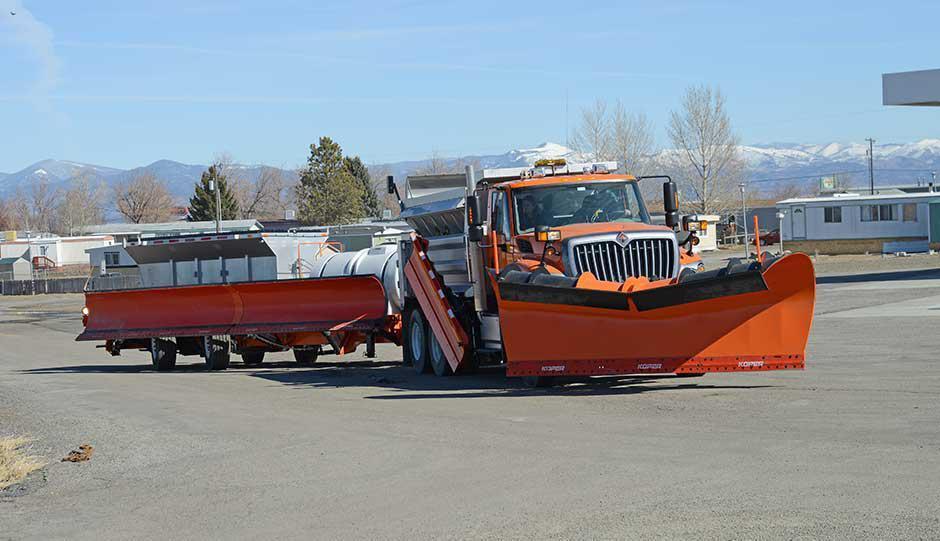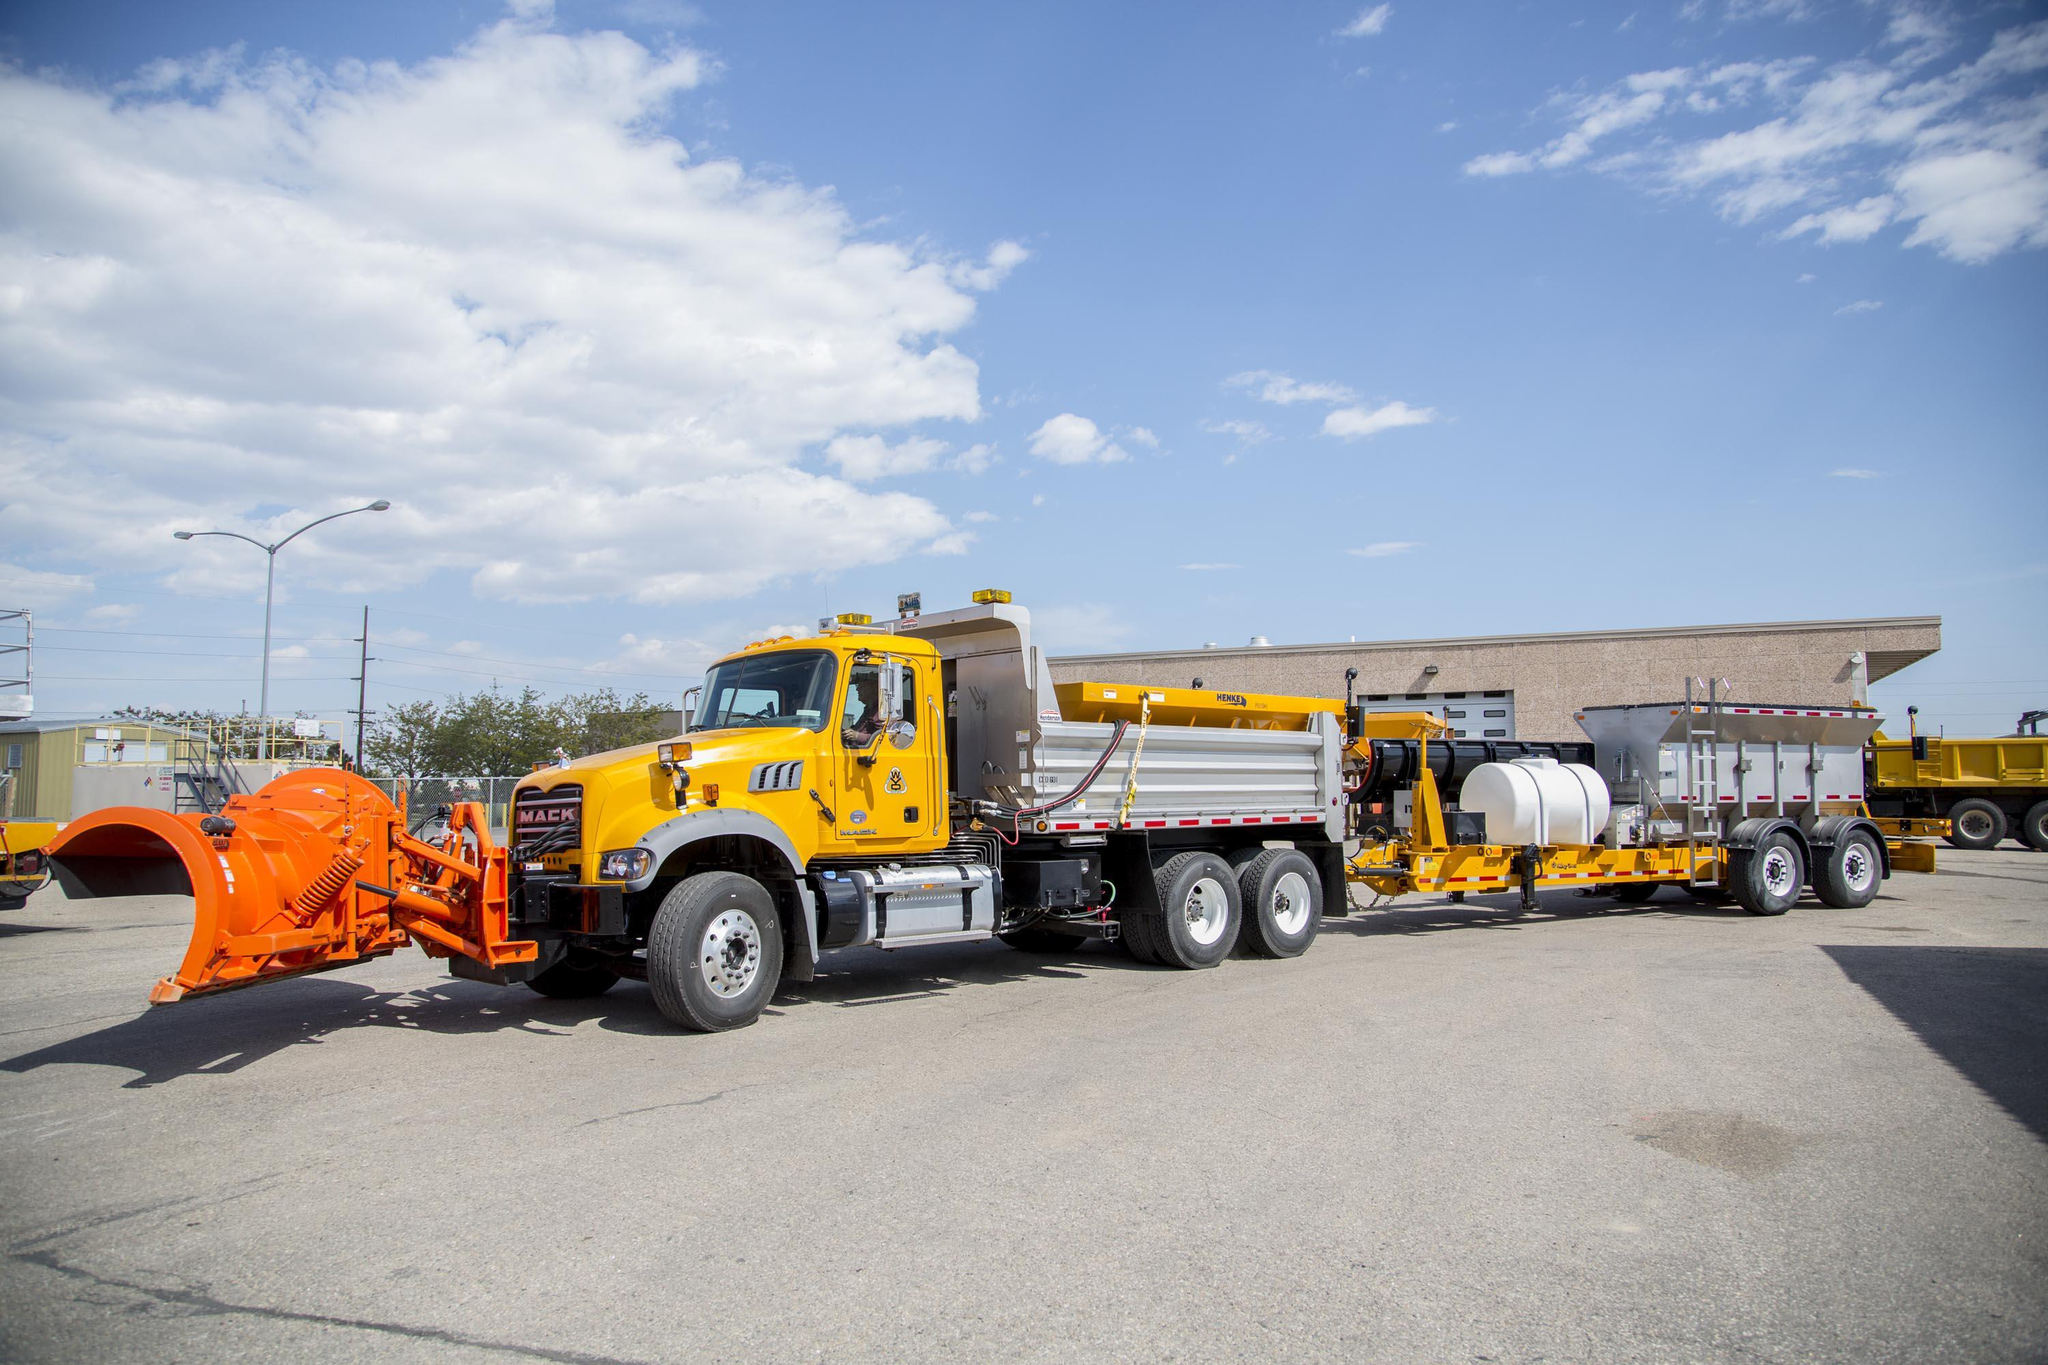The first image is the image on the left, the second image is the image on the right. Analyze the images presented: Is the assertion "At the center of one image is a truck without a snow plow attached in front, and the truck has a yellow cab." valid? Answer yes or no. No. The first image is the image on the left, the second image is the image on the right. Assess this claim about the two images: "A yellow truck is facing left.". Correct or not? Answer yes or no. Yes. 